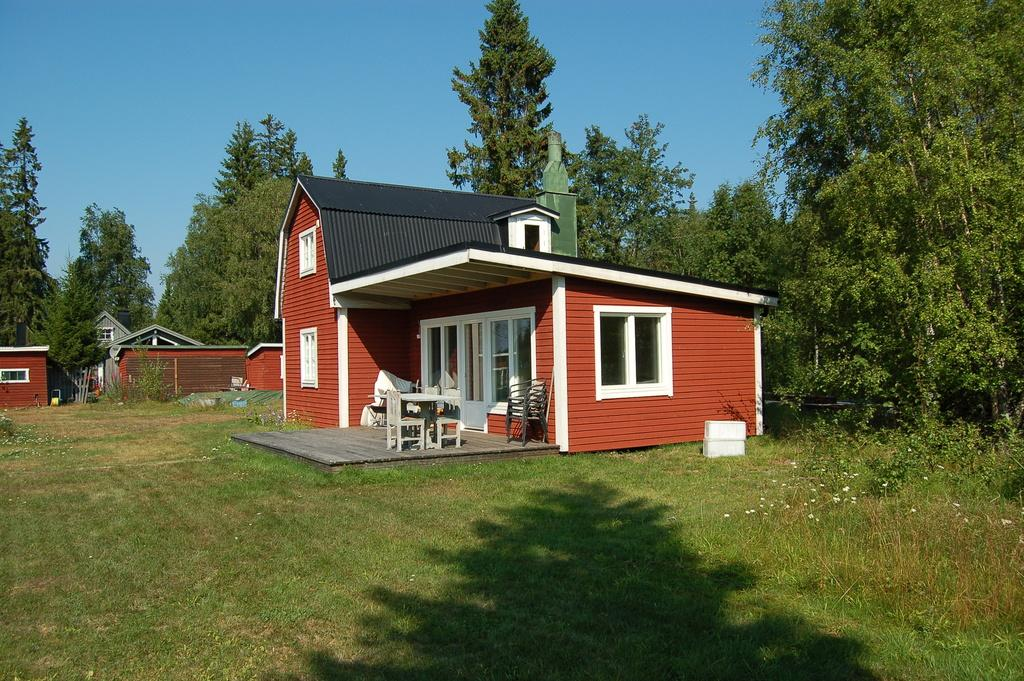What type of structures can be seen in the image? There are houses in the image. What is the color of the houses? The houses are brown in color. What feature of the houses is visible in the image? There are windows visible in the image. What type of vegetation is present in the image? There are trees in the image. What is the color of the trees? The trees are green in color. What can be seen above the houses and trees in the image? The sky is blue in color. What type of beast is roaming around the houses in the image? There is no beast present in the image; it only features houses, trees, and a blue sky. 